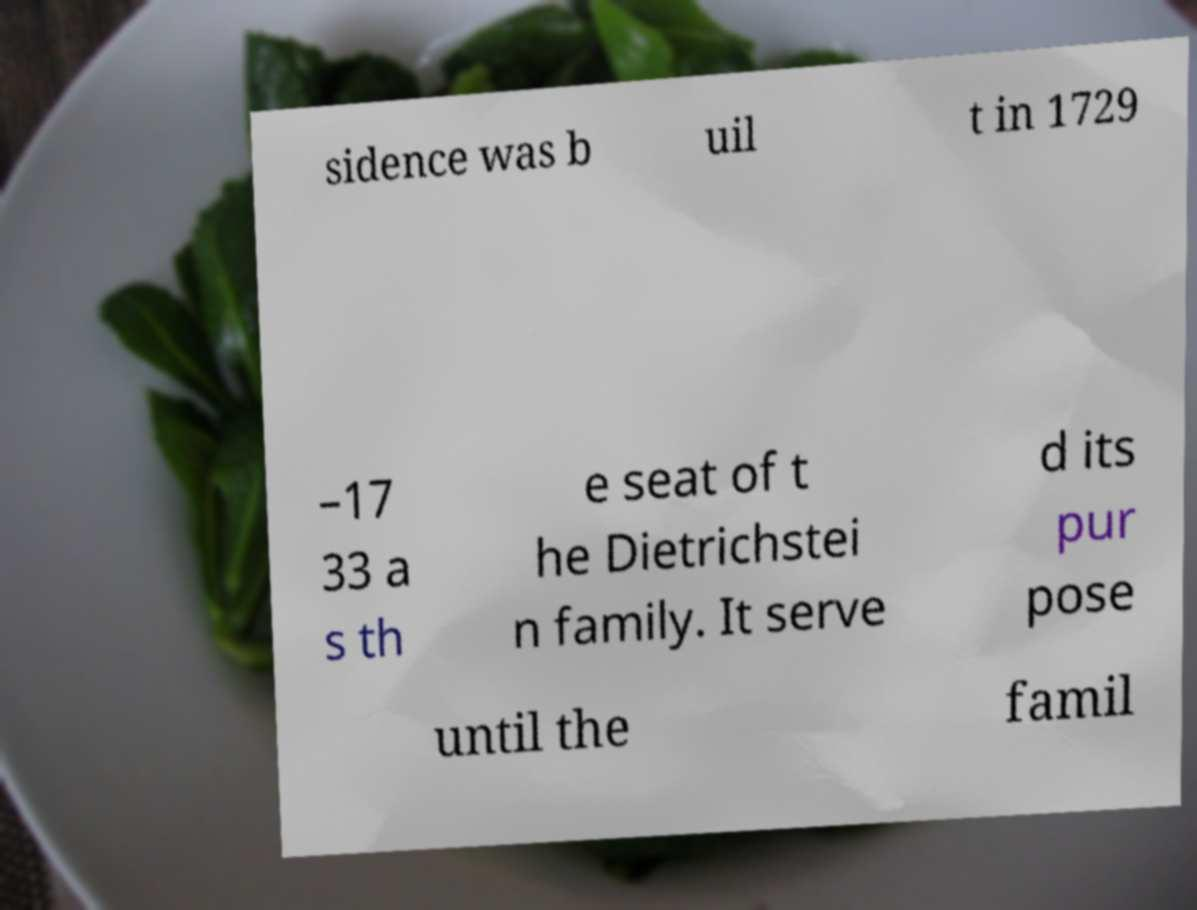I need the written content from this picture converted into text. Can you do that? sidence was b uil t in 1729 –17 33 a s th e seat of t he Dietrichstei n family. It serve d its pur pose until the famil 